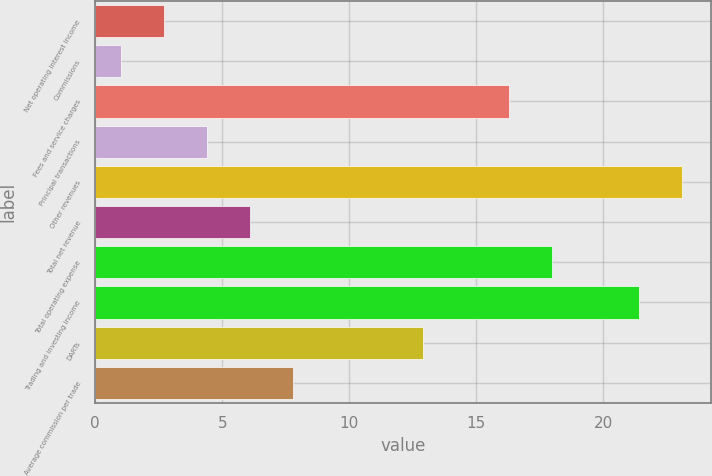<chart> <loc_0><loc_0><loc_500><loc_500><bar_chart><fcel>Net operating interest income<fcel>Commissions<fcel>Fees and service charges<fcel>Principal transactions<fcel>Other revenues<fcel>Total net revenue<fcel>Total operating expense<fcel>Trading and investing income<fcel>DARTs<fcel>Average commission per trade<nl><fcel>2.7<fcel>1<fcel>16.3<fcel>4.4<fcel>23.1<fcel>6.1<fcel>18<fcel>21.4<fcel>12.9<fcel>7.8<nl></chart> 